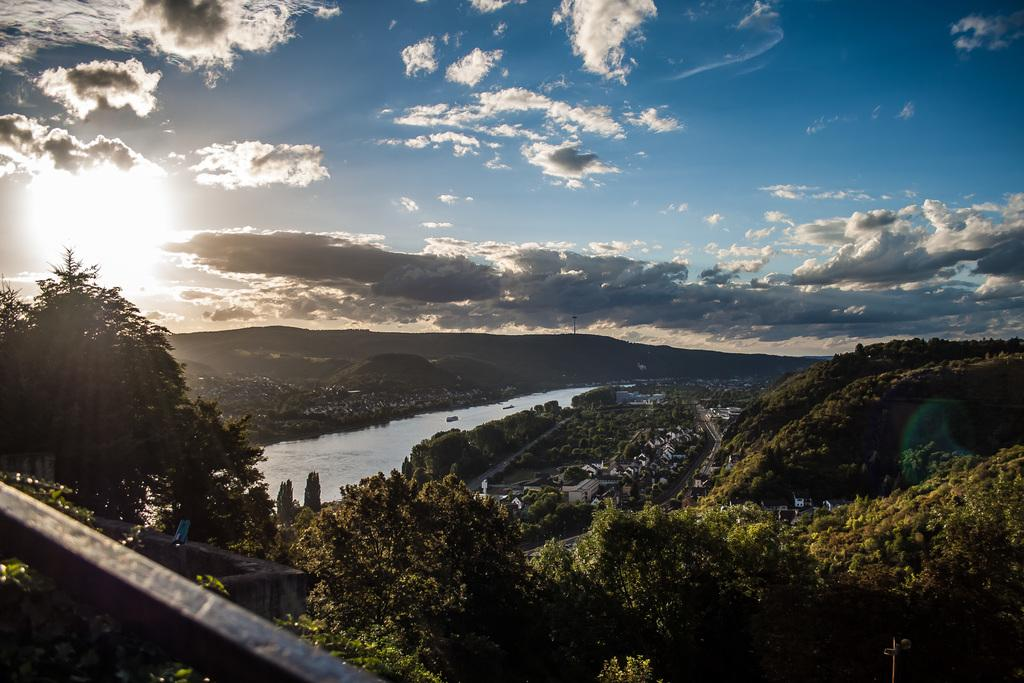What is the main feature in the center of the image? There is water in the center of the image. What type of natural elements can be seen in the image? There are trees and mountains in the image. What type of man-made structures are present in the image? There are buildings in the image. What can be seen in the background of the image? The sky, clouds, and the sun are visible in the background of the image. Where is the market located in the image? There is no market present in the image. What type of seat can be seen in the image? There are no seats visible in the image. 